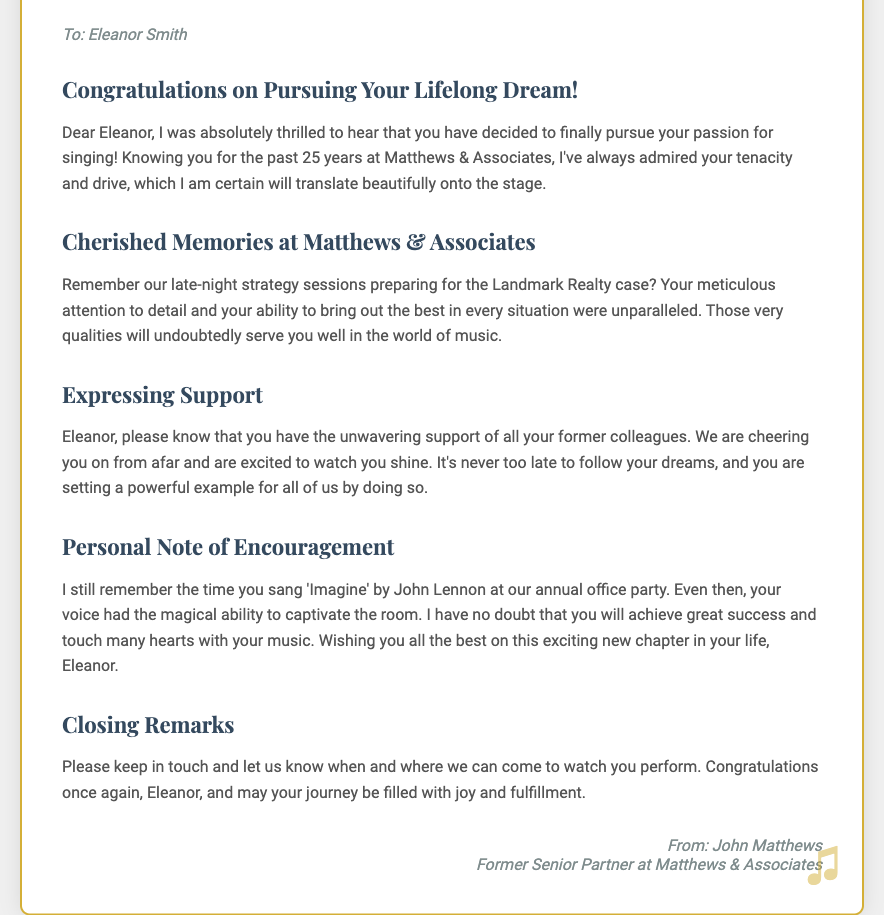What is the sender's name? The sender's name is mentioned at the bottom of the note, identifying them as John Matthews.
Answer: John Matthews What is the document's main purpose? The main purpose is expressed in the title, which indicates it is a congratulatory note supporting Eleanor's decision to pursue singing.
Answer: Congratulatory note How many years did the sender and receiver work together? The sender mentions knowing Eleanor for the past 25 years at Matthews & Associates, indicating their long-standing professional relationship.
Answer: 25 years Which song did Eleanor sing at the office party? The document reminds of a specific song Eleanor sang at an annual office party, which is referenced in a personal note of encouragement.
Answer: 'Imagine' What profession did John Matthews hold? The sender describes their position in the closing remarks, identifying their role within the firm.
Answer: Former Senior Partner What qualities of Eleanor are highlighted in the note? The sender admires Eleanor's tenacity and drive, indicating the qualities they believe will serve her well in her new pursuit.
Answer: Tenacity and drive What did the sender request Eleanor to do? The sender wishes for Eleanor to keep in touch and inform them about her performances, expressing a desire to support her journey.
Answer: Keep in touch What is the overall tone of the note? The language and sentiment used throughout the note convey a supportive and encouraging tone, celebrating Eleanor's new endeavor.
Answer: Supportive and encouraging 